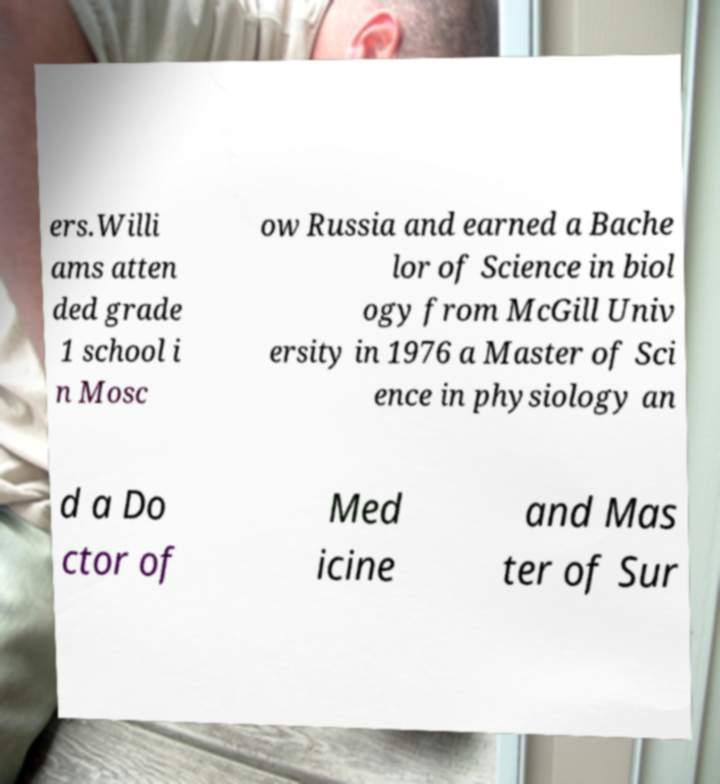Please read and relay the text visible in this image. What does it say? ers.Willi ams atten ded grade 1 school i n Mosc ow Russia and earned a Bache lor of Science in biol ogy from McGill Univ ersity in 1976 a Master of Sci ence in physiology an d a Do ctor of Med icine and Mas ter of Sur 